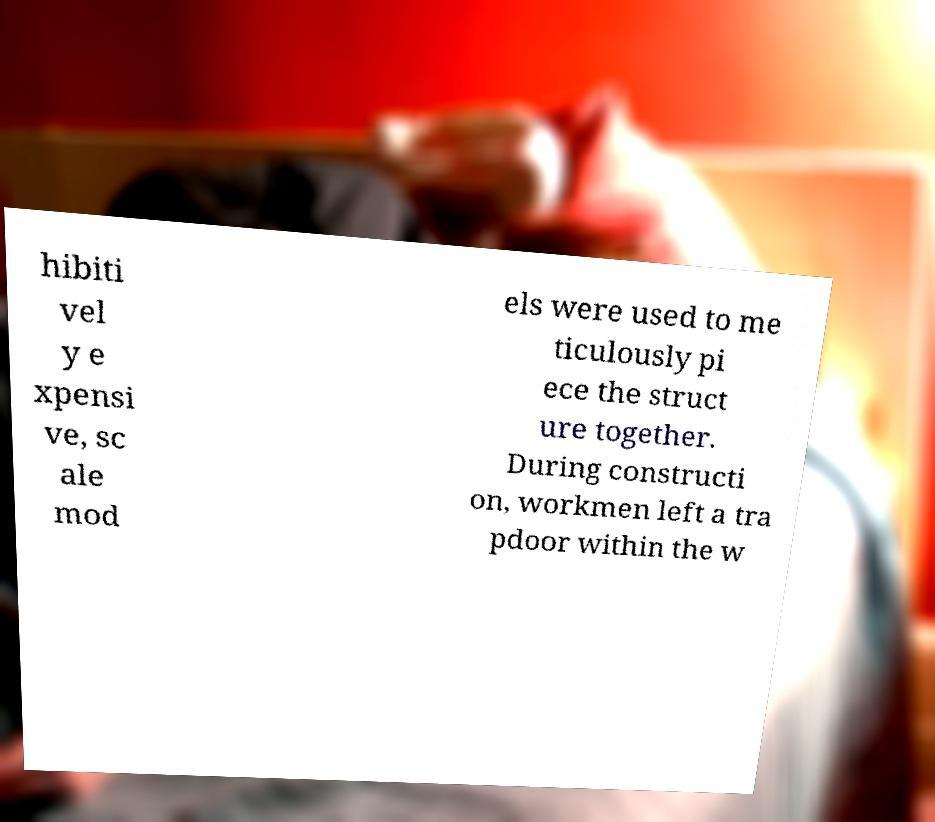Can you read and provide the text displayed in the image?This photo seems to have some interesting text. Can you extract and type it out for me? hibiti vel y e xpensi ve, sc ale mod els were used to me ticulously pi ece the struct ure together. During constructi on, workmen left a tra pdoor within the w 